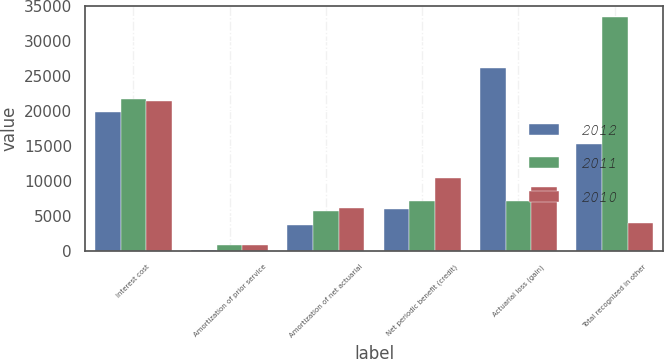Convert chart. <chart><loc_0><loc_0><loc_500><loc_500><stacked_bar_chart><ecel><fcel>Interest cost<fcel>Amortization of prior service<fcel>Amortization of net actuarial<fcel>Net periodic benefit (credit)<fcel>Actuarial loss (gain)<fcel>Total recognized in other<nl><fcel>2012<fcel>19888<fcel>133<fcel>3646<fcel>5996<fcel>26184<fcel>15195<nl><fcel>2011<fcel>21707<fcel>801<fcel>5598<fcel>7068<fcel>7068<fcel>33423<nl><fcel>2010<fcel>21364<fcel>801<fcel>6067<fcel>10394<fcel>9151<fcel>3885<nl></chart> 